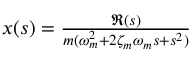Convert formula to latex. <formula><loc_0><loc_0><loc_500><loc_500>\begin{array} { r } { x ( s ) = \frac { \Re ( s ) } { m ( \omega _ { m } ^ { 2 } + 2 \zeta _ { m } \omega _ { m } s + s ^ { 2 } ) } } \end{array}</formula> 